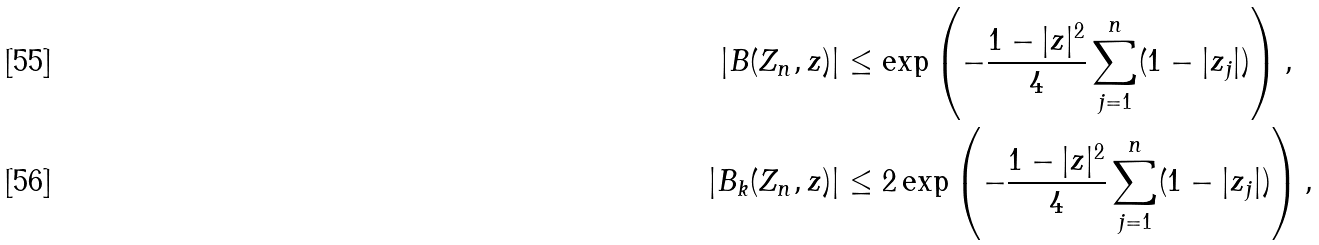Convert formula to latex. <formula><loc_0><loc_0><loc_500><loc_500>| B ( Z _ { n } , z ) | & \leq \exp \left ( - \frac { 1 - | z | ^ { 2 } } { 4 } \sum _ { j = 1 } ^ { n } ( 1 - | z _ { j } | ) \right ) , \\ | B _ { k } ( Z _ { n } , z ) | & \leq 2 \exp \left ( - \frac { 1 - | z | ^ { 2 } } { 4 } \sum _ { j = 1 } ^ { n } ( 1 - | z _ { j } | ) \right ) ,</formula> 